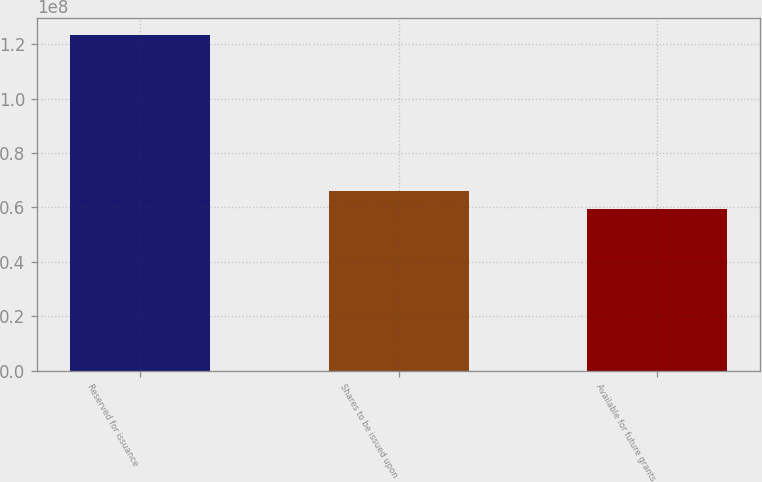<chart> <loc_0><loc_0><loc_500><loc_500><bar_chart><fcel>Reserved for issuance<fcel>Shares to be issued upon<fcel>Available for future grants<nl><fcel>1.23297e+08<fcel>6.59531e+07<fcel>5.95816e+07<nl></chart> 